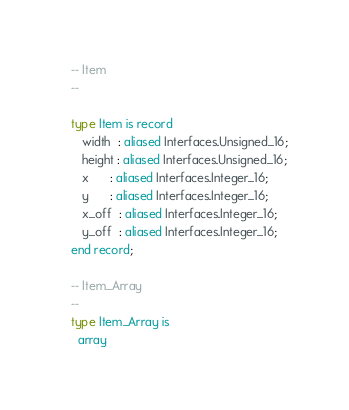<code> <loc_0><loc_0><loc_500><loc_500><_Ada_>
   -- Item
   --

   type Item is record
      width  : aliased Interfaces.Unsigned_16;
      height : aliased Interfaces.Unsigned_16;
      x      : aliased Interfaces.Integer_16;
      y      : aliased Interfaces.Integer_16;
      x_off  : aliased Interfaces.Integer_16;
      y_off  : aliased Interfaces.Integer_16;
   end record;

   -- Item_Array
   --
   type Item_Array is
     array</code> 